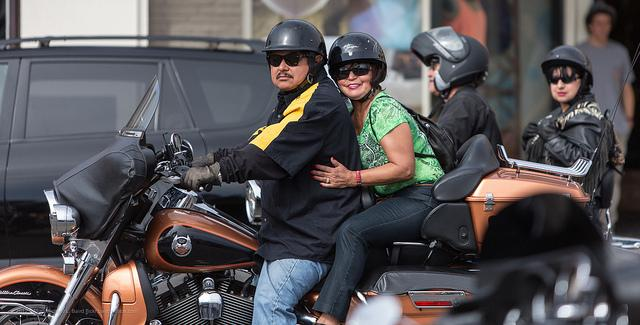Who is the happiest in the picture?

Choices:
A) back woman
B) front man
C) front woman
D) back man front woman 